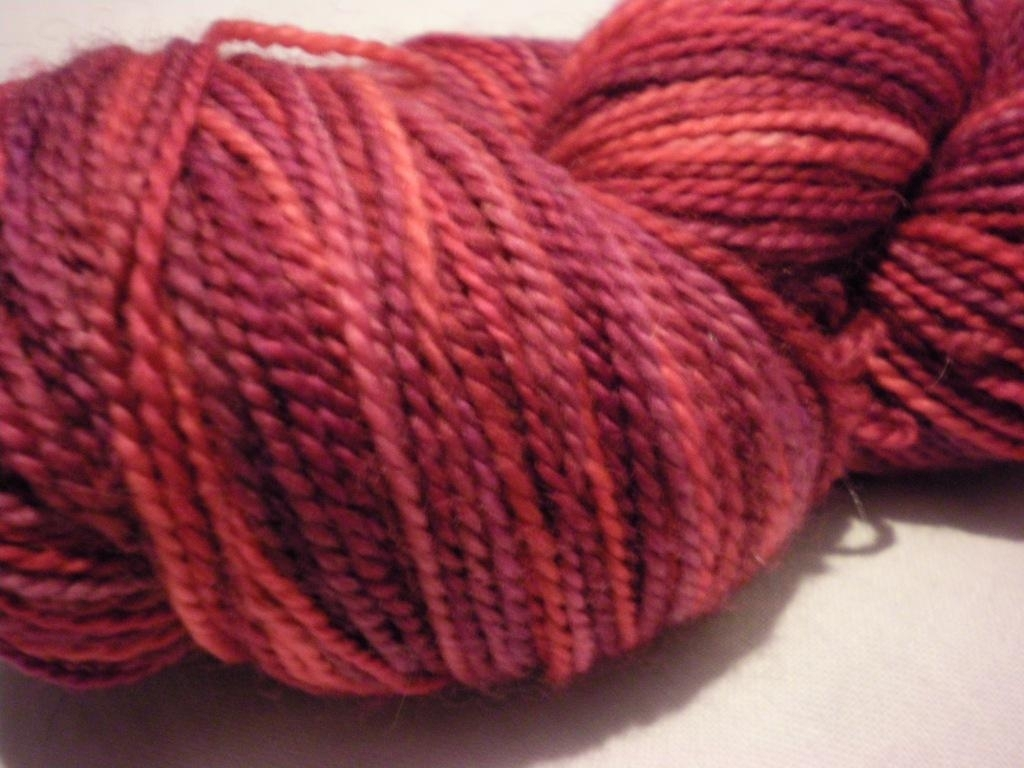What is the texture of the material in this image? The material in the image appears to be a skein of yarn with a soft and twisted texture, suggesting that it may be a wool blend which is often used in knitting or crocheting. 